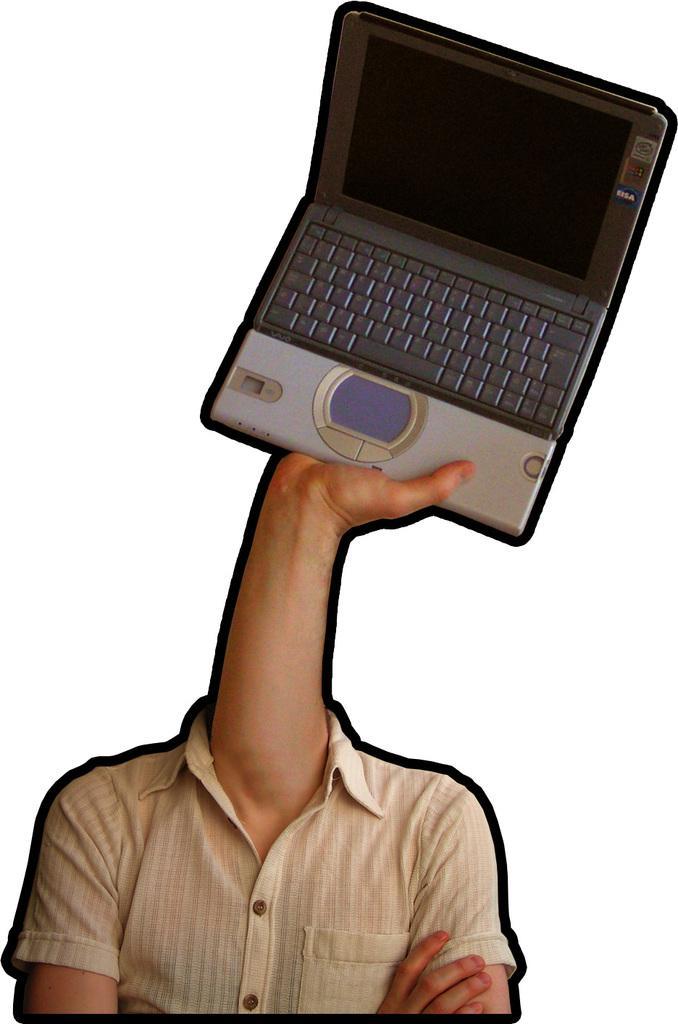Can you describe this image briefly? In this image I can see a edited picture where a hand of a person is holding a laptop. I can also see shirt and one more hand. I can see white colour in background. 